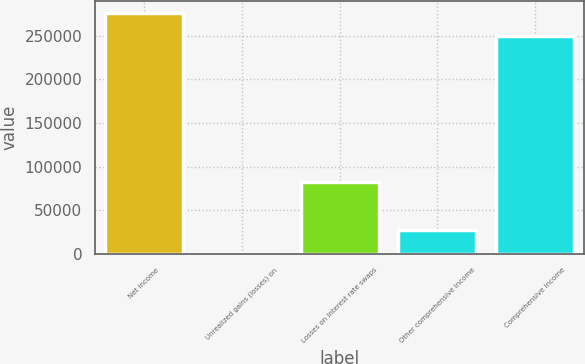Convert chart. <chart><loc_0><loc_0><loc_500><loc_500><bar_chart><fcel>Net income<fcel>Unrealized gains (losses) on<fcel>Losses on interest rate swaps<fcel>Other comprehensive income<fcel>Comprehensive income<nl><fcel>276362<fcel>214<fcel>81922.6<fcel>27450.2<fcel>249126<nl></chart> 